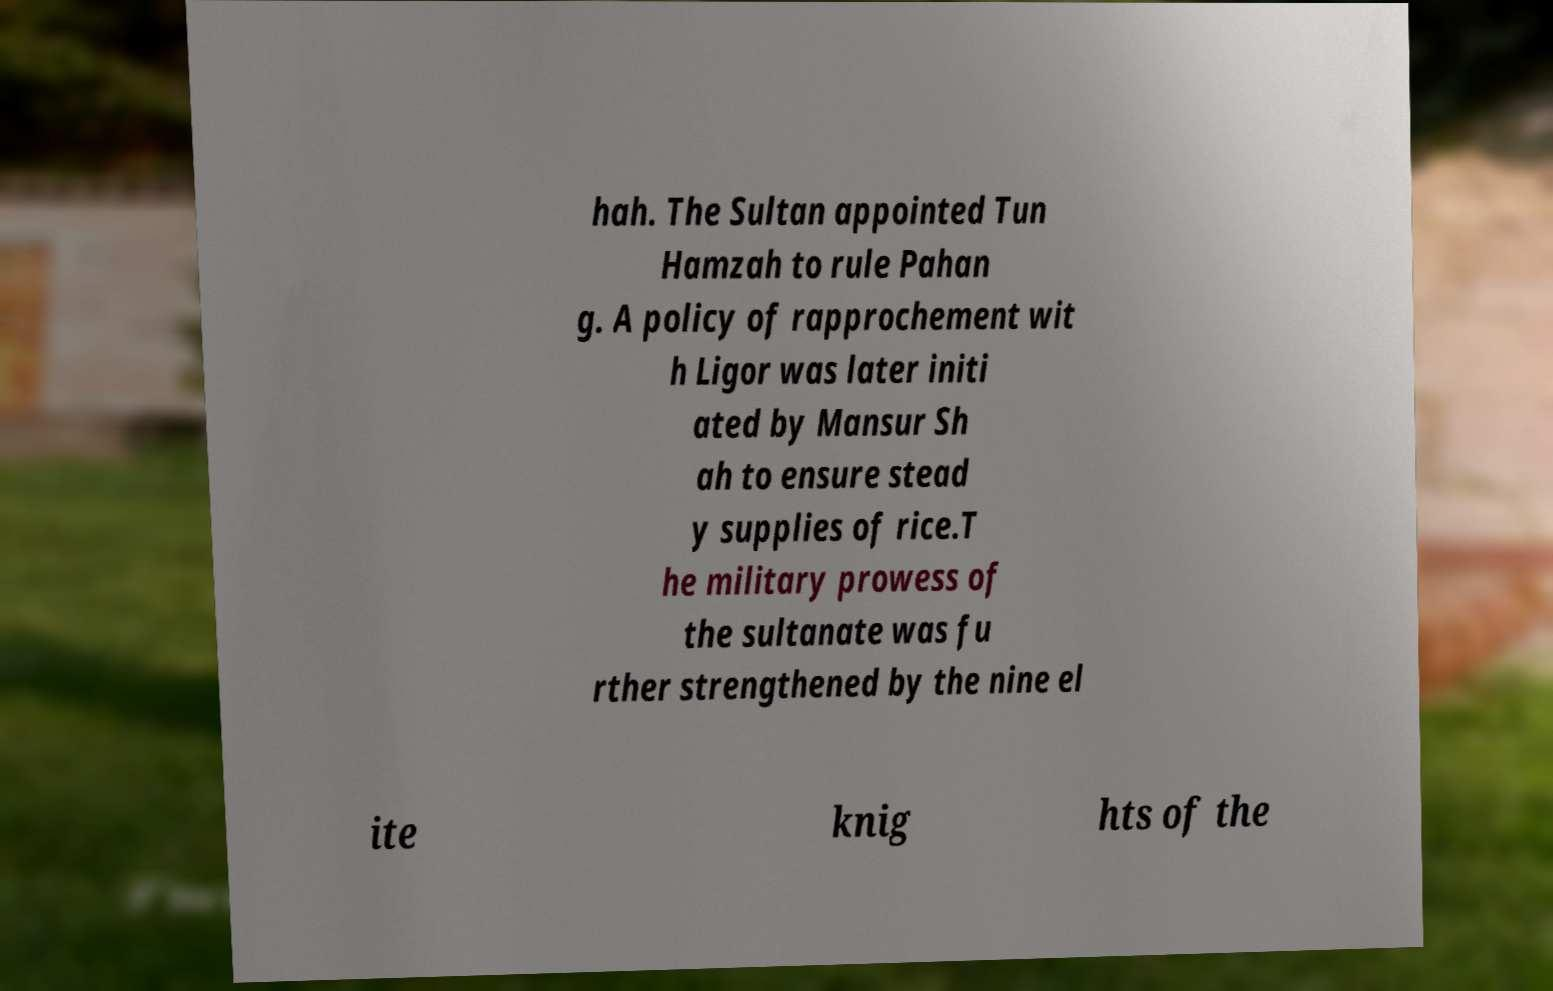Can you read and provide the text displayed in the image?This photo seems to have some interesting text. Can you extract and type it out for me? hah. The Sultan appointed Tun Hamzah to rule Pahan g. A policy of rapprochement wit h Ligor was later initi ated by Mansur Sh ah to ensure stead y supplies of rice.T he military prowess of the sultanate was fu rther strengthened by the nine el ite knig hts of the 